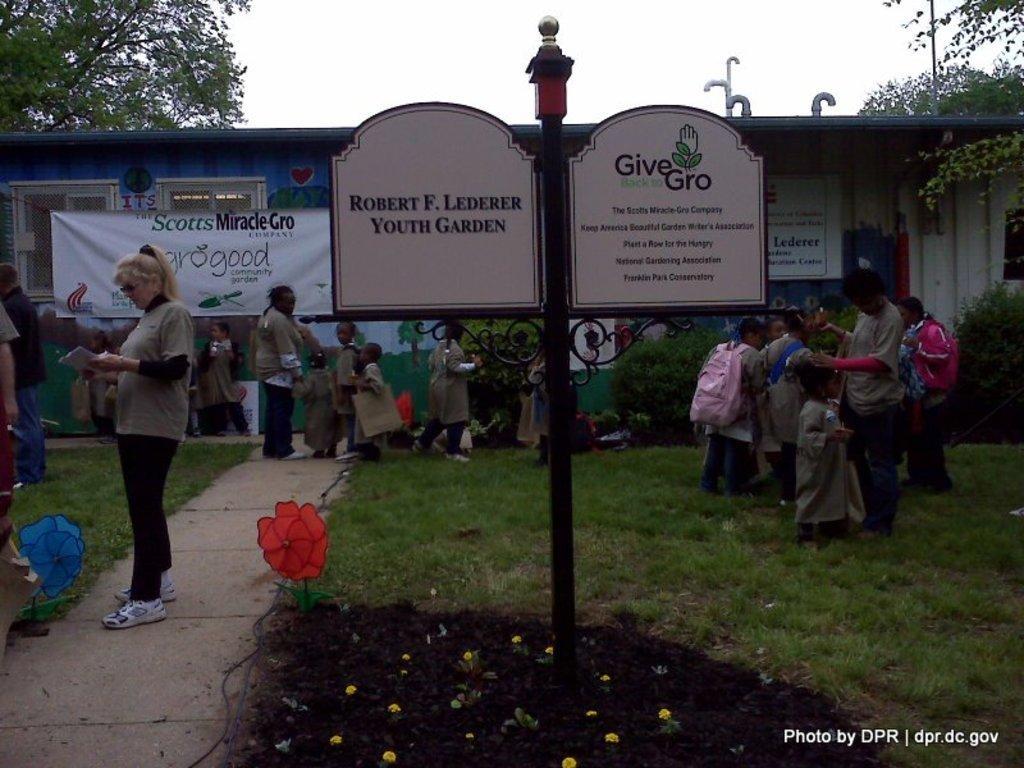How would you summarize this image in a sentence or two? In the center of the image there is a pole with some text on the board. At the bottom of the image there is grass, flowers. In the background of the image there is a house. There is a banner. There are people. To right side bottom of the image there is text. At the top of the image there is sky. 